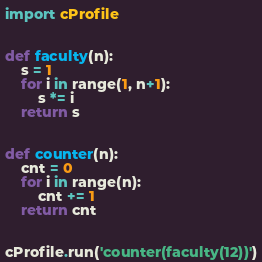<code> <loc_0><loc_0><loc_500><loc_500><_Python_>import cProfile


def faculty(n):
    s = 1
    for i in range(1, n+1):
        s *= i
    return s


def counter(n):
    cnt = 0
    for i in range(n):
        cnt += 1
    return cnt


cProfile.run('counter(faculty(12))')
</code> 